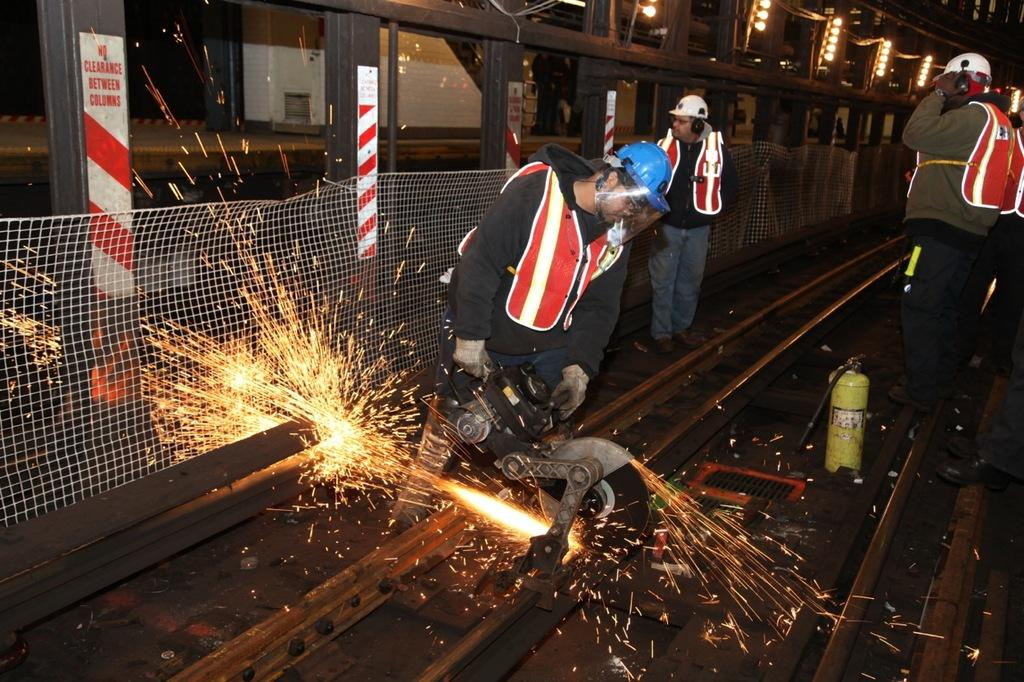Who or what is the main subject in the image? There is a person in the image. What is the person holding in the image? The person is holding a metal cutter machine. What type of structure can be seen in the image? There is fencing in the image. What else can be seen in the image besides the person and fencing? There are tracks and other people in the image. What letters are being used by the person in the image to answer questions? There are no letters or questions present in the image; the person is holding a metal cutter machine. 